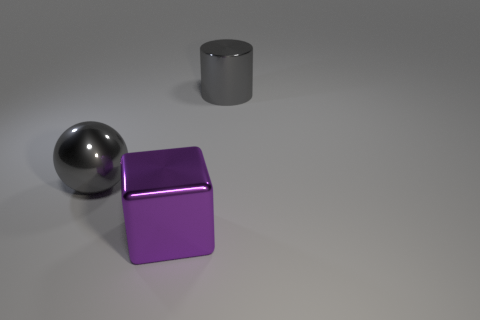There is a large gray metal thing on the right side of the metallic object that is in front of the large metal sphere; what shape is it?
Your response must be concise. Cylinder. There is a big gray cylinder; how many big metallic cubes are in front of it?
Offer a terse response. 1. Does the large block have the same material as the large gray thing in front of the large cylinder?
Your response must be concise. Yes. Is there a brown rubber ball of the same size as the cube?
Give a very brief answer. No. Are there an equal number of large gray cylinders on the left side of the large gray metallic cylinder and objects?
Your response must be concise. No. The gray metallic cylinder is what size?
Give a very brief answer. Large. How many purple shiny things are right of the gray metallic thing that is in front of the large metallic cylinder?
Ensure brevity in your answer.  1. The big shiny object that is both in front of the large gray cylinder and behind the large metal cube has what shape?
Provide a short and direct response. Sphere. What number of big metal things have the same color as the cylinder?
Offer a very short reply. 1. Is there a big gray ball that is to the right of the gray object that is on the right side of the large metallic ball left of the large purple shiny cube?
Your answer should be very brief. No. 